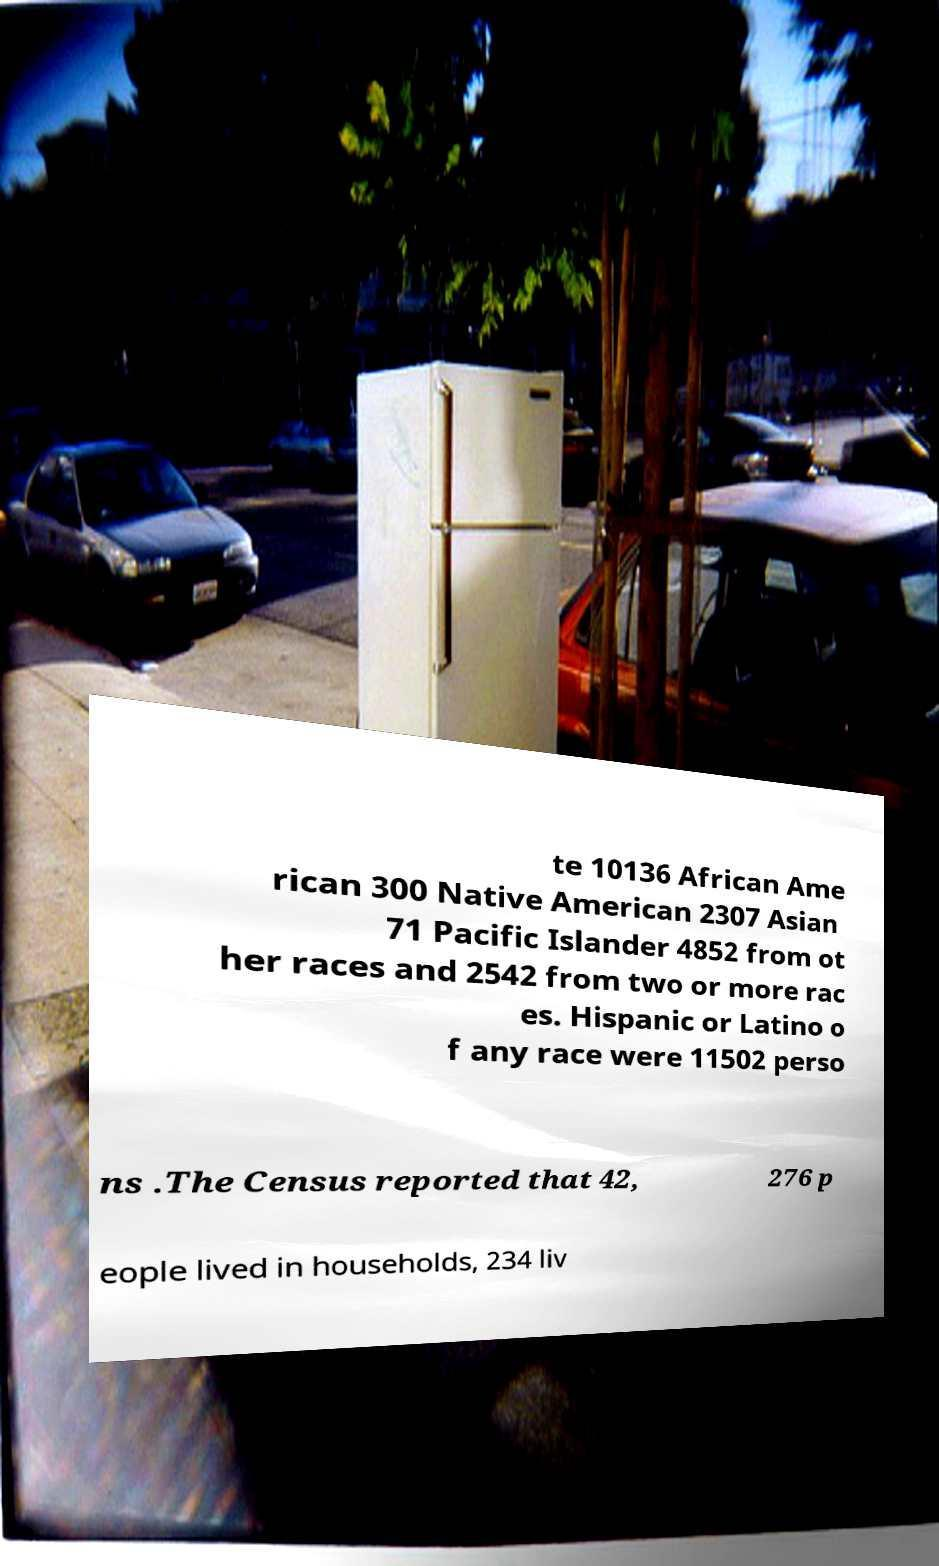There's text embedded in this image that I need extracted. Can you transcribe it verbatim? te 10136 African Ame rican 300 Native American 2307 Asian 71 Pacific Islander 4852 from ot her races and 2542 from two or more rac es. Hispanic or Latino o f any race were 11502 perso ns .The Census reported that 42, 276 p eople lived in households, 234 liv 